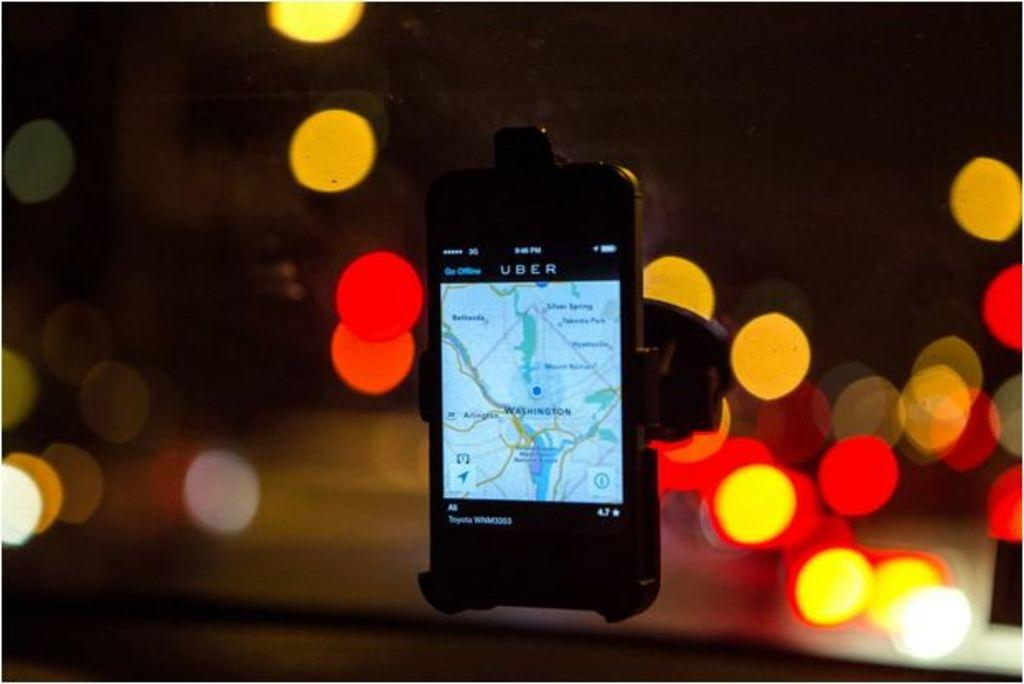Provide a one-sentence caption for the provided image. A phone is being used as a navigation system in an Uber. 